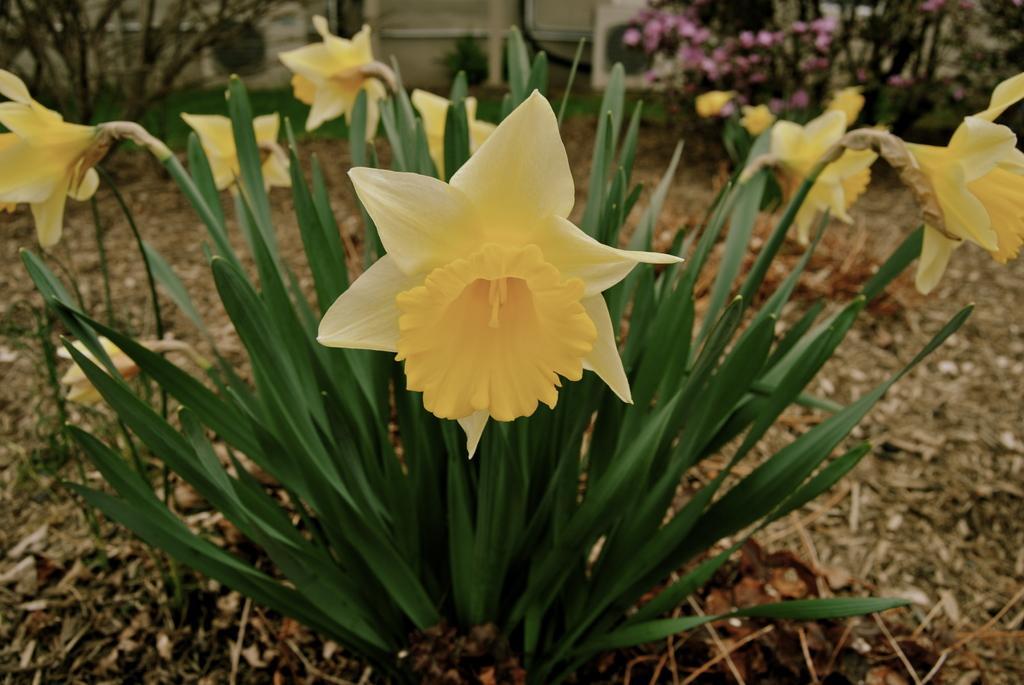Describe this image in one or two sentences. In this image we can see some plants with flowers. 